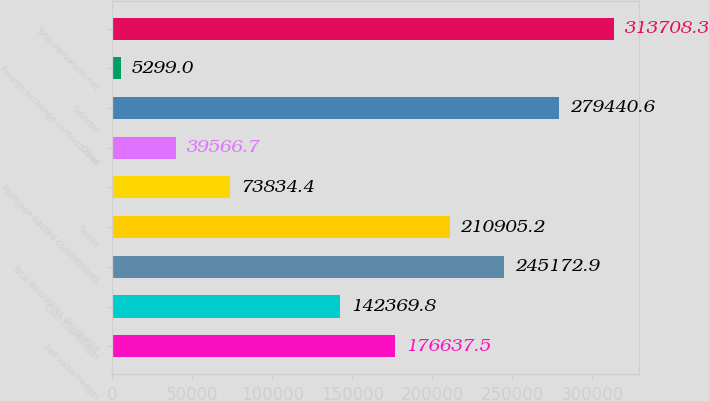<chart> <loc_0><loc_0><loc_500><loc_500><bar_chart><fcel>Fair value hedges<fcel>Cash flow hedges<fcel>Total derivatives designated<fcel>Swaps<fcel>Mortgage-backed commitments<fcel>Other<fcel>Subtotal<fcel>Foreign exchange contracts and<fcel>Total derivatives not<nl><fcel>176638<fcel>142370<fcel>245173<fcel>210905<fcel>73834.4<fcel>39566.7<fcel>279441<fcel>5299<fcel>313708<nl></chart> 